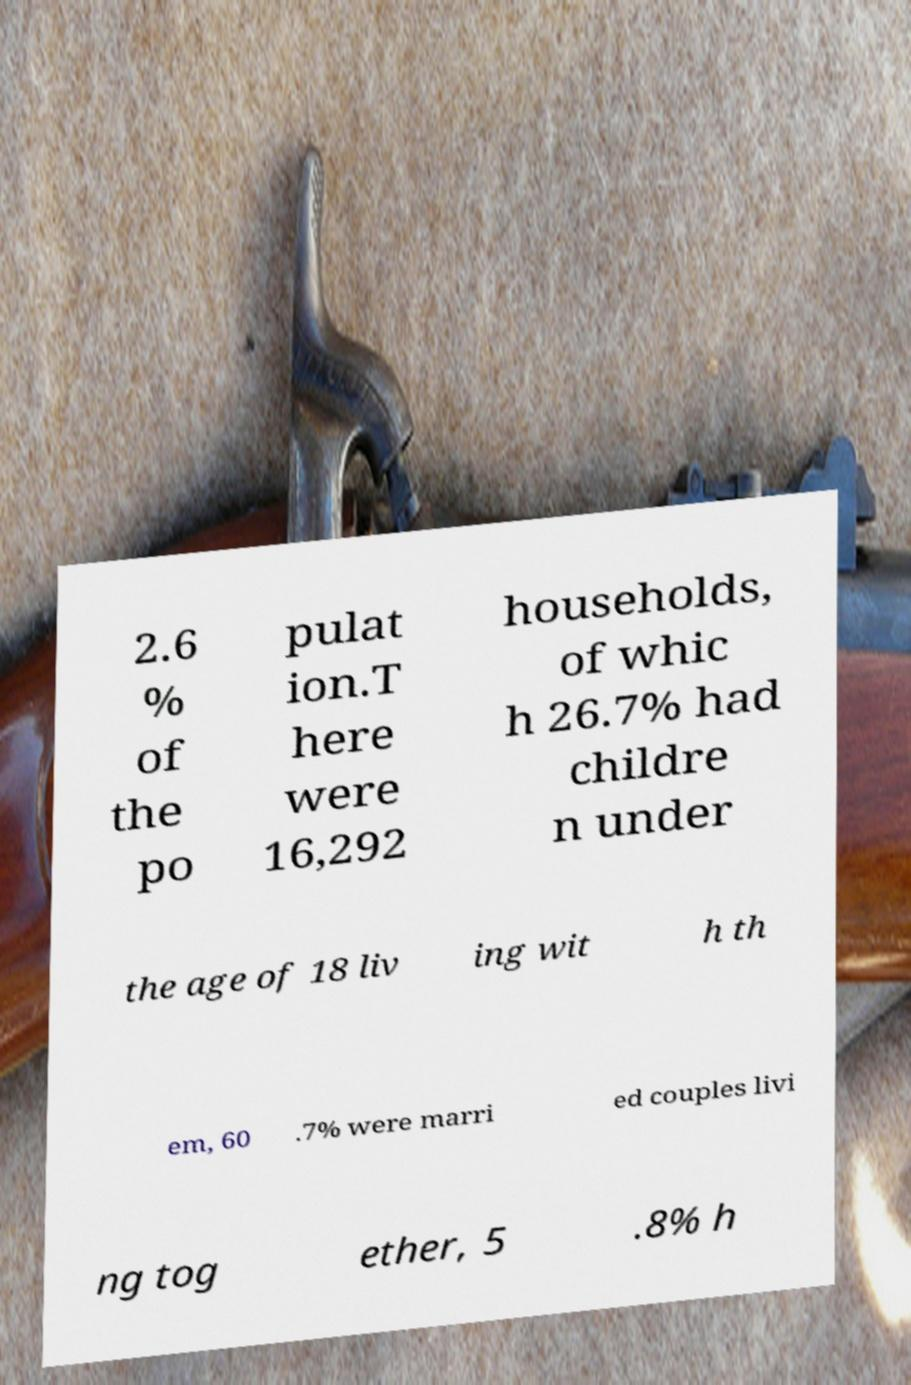Can you accurately transcribe the text from the provided image for me? 2.6 % of the po pulat ion.T here were 16,292 households, of whic h 26.7% had childre n under the age of 18 liv ing wit h th em, 60 .7% were marri ed couples livi ng tog ether, 5 .8% h 